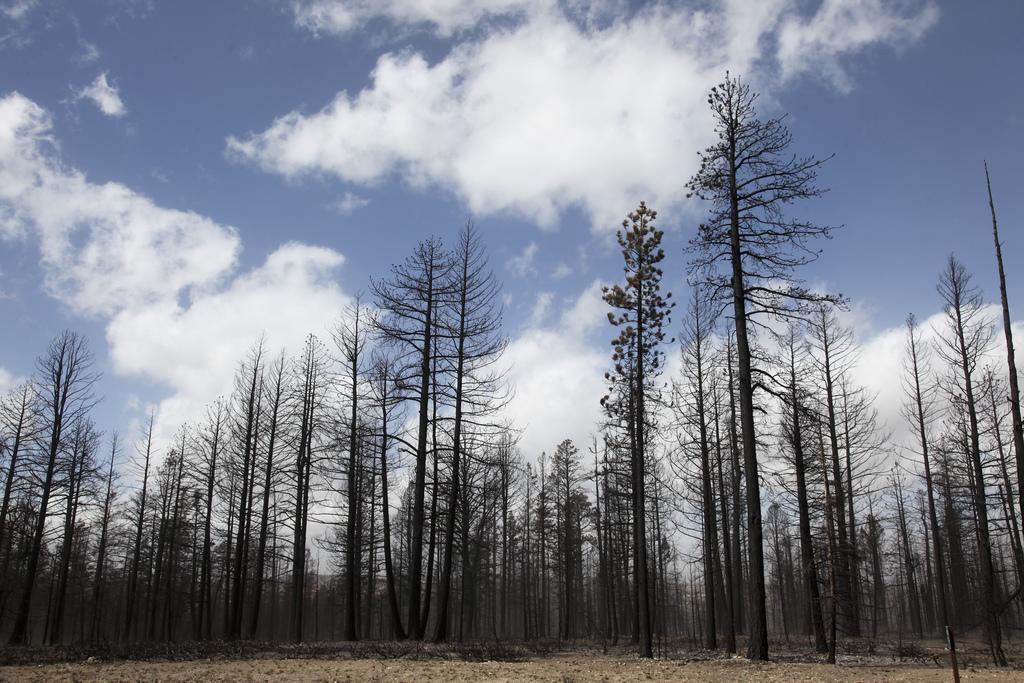How would you summarize this image in a sentence or two? There are trees and there are clouds in the sky. 